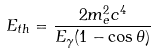<formula> <loc_0><loc_0><loc_500><loc_500>E _ { t h } = \frac { 2 m _ { e } ^ { 2 } c ^ { 4 } } { E _ { \gamma } ( 1 - \cos \theta ) }</formula> 